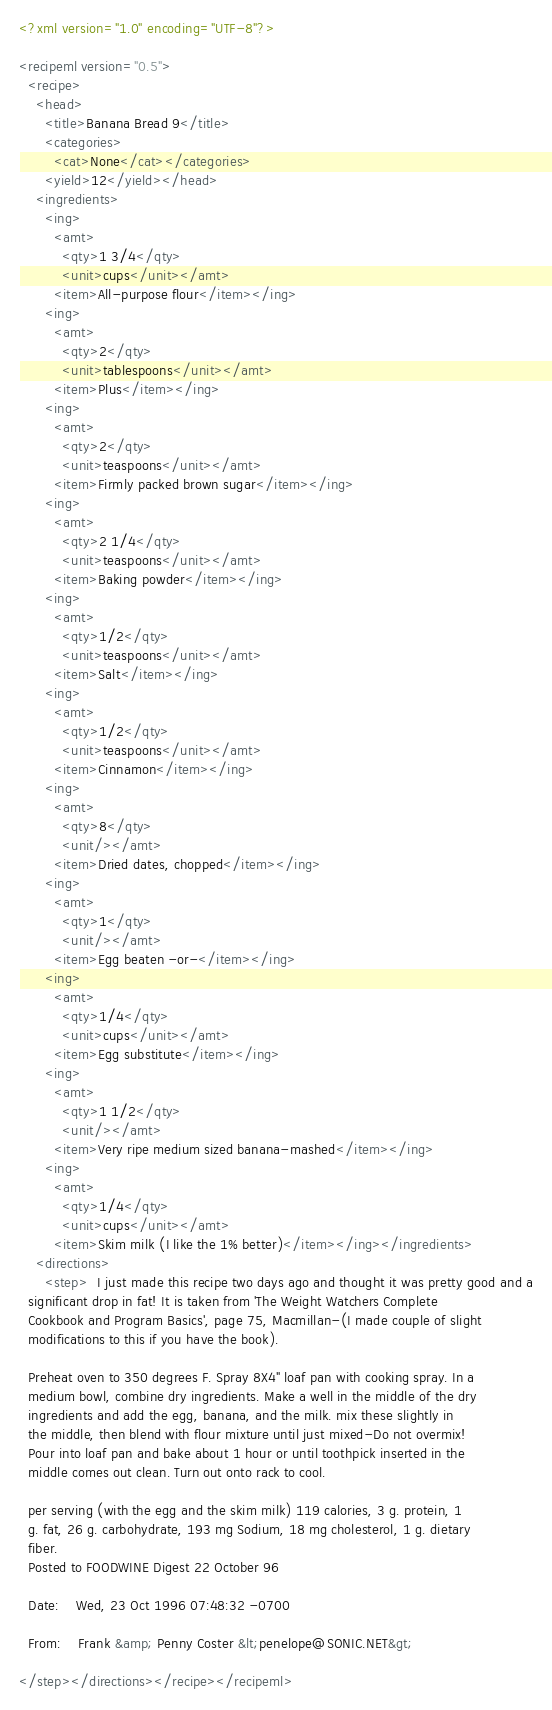<code> <loc_0><loc_0><loc_500><loc_500><_XML_><?xml version="1.0" encoding="UTF-8"?>

<recipeml version="0.5">
  <recipe>
    <head>
      <title>Banana Bread 9</title>
      <categories>
        <cat>None</cat></categories>
      <yield>12</yield></head>
    <ingredients>
      <ing>
        <amt>
          <qty>1 3/4</qty>
          <unit>cups</unit></amt>
        <item>All-purpose flour</item></ing>
      <ing>
        <amt>
          <qty>2</qty>
          <unit>tablespoons</unit></amt>
        <item>Plus</item></ing>
      <ing>
        <amt>
          <qty>2</qty>
          <unit>teaspoons</unit></amt>
        <item>Firmly packed brown sugar</item></ing>
      <ing>
        <amt>
          <qty>2 1/4</qty>
          <unit>teaspoons</unit></amt>
        <item>Baking powder</item></ing>
      <ing>
        <amt>
          <qty>1/2</qty>
          <unit>teaspoons</unit></amt>
        <item>Salt</item></ing>
      <ing>
        <amt>
          <qty>1/2</qty>
          <unit>teaspoons</unit></amt>
        <item>Cinnamon</item></ing>
      <ing>
        <amt>
          <qty>8</qty>
          <unit/></amt>
        <item>Dried dates, chopped</item></ing>
      <ing>
        <amt>
          <qty>1</qty>
          <unit/></amt>
        <item>Egg beaten -or-</item></ing>
      <ing>
        <amt>
          <qty>1/4</qty>
          <unit>cups</unit></amt>
        <item>Egg substitute</item></ing>
      <ing>
        <amt>
          <qty>1 1/2</qty>
          <unit/></amt>
        <item>Very ripe medium sized banana-mashed</item></ing>
      <ing>
        <amt>
          <qty>1/4</qty>
          <unit>cups</unit></amt>
        <item>Skim milk (I like the 1% better)</item></ing></ingredients>
    <directions>
      <step>  I just made this recipe two days ago and thought it was pretty good and a
  significant drop in fat! It is taken from 'The Weight Watchers Complete
  Cookbook and Program Basics', page 75, Macmillan-(I made couple of slight
  modifications to this if you have the book).
  
  Preheat oven to 350 degrees F. Spray 8X4" loaf pan with cooking spray. In a
  medium bowl, combine dry ingredients. Make a well in the middle of the dry
  ingredients and add the egg, banana, and the milk. mix these slightly in
  the middle, then blend with flour mixture until just mixed-Do not overmix!
  Pour into loaf pan and bake about 1 hour or until toothpick inserted in the
  middle comes out clean. Turn out onto rack to cool.
  
  per serving (with the egg and the skim milk) 119 calories, 3 g. protein, 1
  g. fat, 26 g. carbohydrate, 193 mg Sodium, 18 mg cholesterol, 1 g. dietary
  fiber.
  Posted to FOODWINE Digest 22 October 96
  
  Date:    Wed, 23 Oct 1996 07:48:32 -0700
  
  From:    Frank &amp; Penny Coster &lt;penelope@SONIC.NET&gt;
 
</step></directions></recipe></recipeml>
</code> 